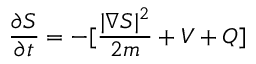Convert formula to latex. <formula><loc_0><loc_0><loc_500><loc_500>\frac { \partial S } { \partial t } = - [ \frac { | \nabla S | ^ { 2 } } { 2 m } + V + Q ]</formula> 